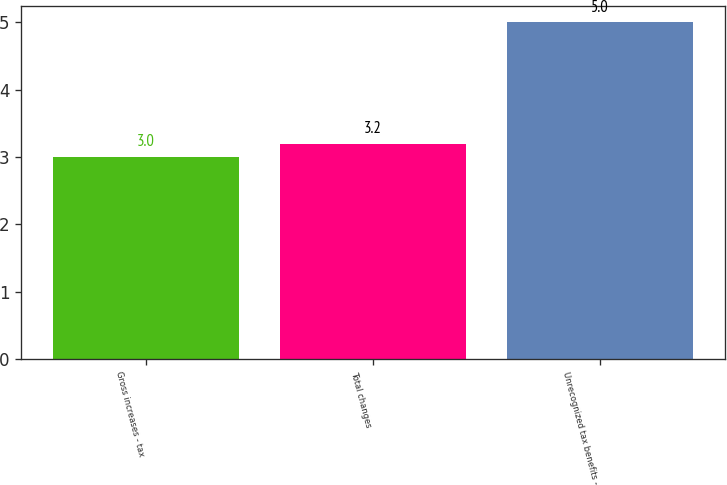Convert chart. <chart><loc_0><loc_0><loc_500><loc_500><bar_chart><fcel>Gross increases - tax<fcel>Total changes<fcel>Unrecognized tax benefits -<nl><fcel>3<fcel>3.2<fcel>5<nl></chart> 